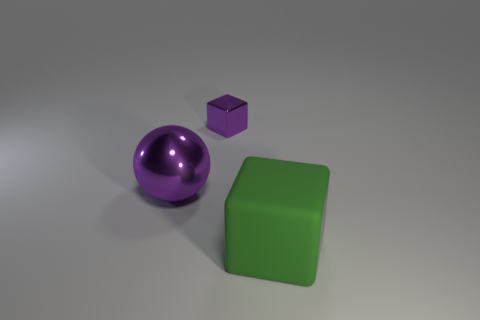Add 3 purple metal things. How many objects exist? 6 Subtract all purple cubes. How many cubes are left? 1 Subtract all balls. How many objects are left? 2 Subtract 2 cubes. How many cubes are left? 0 Subtract all brown spheres. Subtract all red blocks. How many spheres are left? 1 Subtract all large purple spheres. Subtract all purple objects. How many objects are left? 0 Add 2 small things. How many small things are left? 3 Add 3 small purple objects. How many small purple objects exist? 4 Subtract 0 cyan balls. How many objects are left? 3 